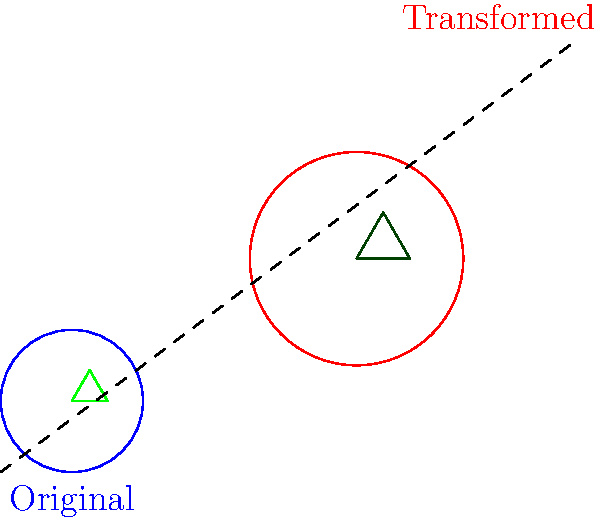A streaming platform's logo consists of a circle with an inscribed equilateral triangle. To create a dynamic animation effect, you need to dilate the logo by a factor of 1.5 and translate it 2 units right and 1 unit up. If the original circle has a radius of 0.5 units, what will be the area of the transformed circle? Let's approach this step-by-step:

1) The original circle has a radius of 0.5 units. Its area is:
   $$A_1 = \pi r^2 = \pi (0.5)^2 = 0.25\pi$$

2) The logo is dilated by a factor of 1.5. This means all linear dimensions are multiplied by 1.5. The new radius is:
   $$r_2 = 1.5 \times 0.5 = 0.75$$

3) The area of a circle is proportional to the square of its radius. So, the dilation factor for the area is the square of the linear dilation factor:
   $$\text{Area dilation factor} = (1.5)^2 = 2.25$$

4) Therefore, the new area is:
   $$A_2 = 2.25 \times A_1 = 2.25 \times 0.25\pi = 0.5625\pi$$

5) The translation (moving 2 units right and 1 unit up) doesn't affect the area of the circle.

Thus, the area of the transformed circle is $0.5625\pi$ square units.
Answer: $0.5625\pi$ square units 